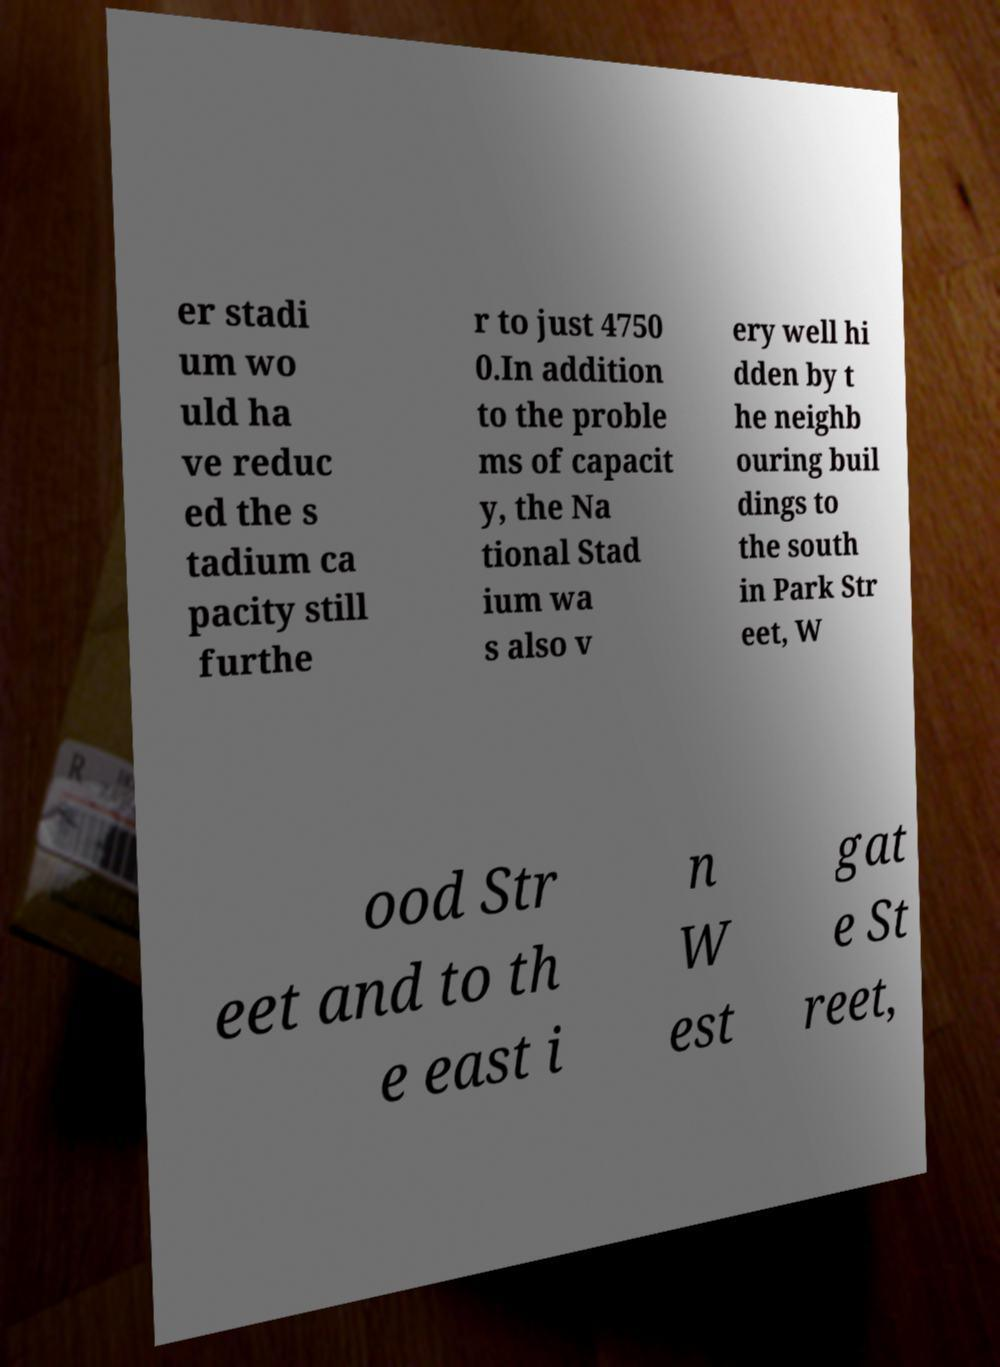There's text embedded in this image that I need extracted. Can you transcribe it verbatim? er stadi um wo uld ha ve reduc ed the s tadium ca pacity still furthe r to just 4750 0.In addition to the proble ms of capacit y, the Na tional Stad ium wa s also v ery well hi dden by t he neighb ouring buil dings to the south in Park Str eet, W ood Str eet and to th e east i n W est gat e St reet, 